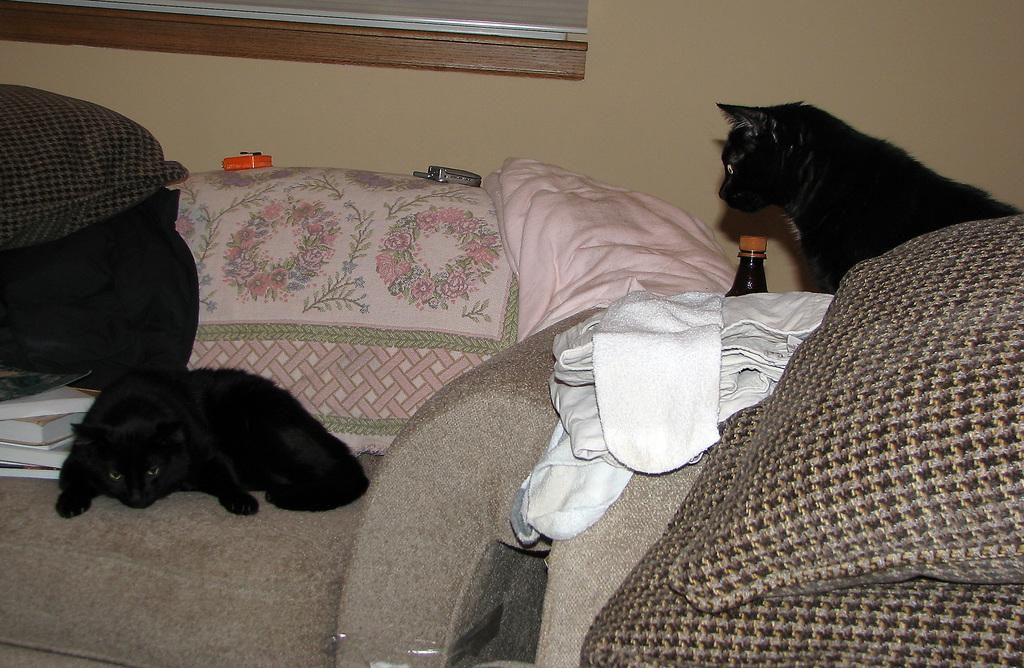What type of animals can be seen in the image? There are cats in the image. What is on the sofa in the image? There are pillows, clothes, and other objects on the sofa. What is visible in the background of the image? There is a wall in the background of the image. What type of nose can be seen on the governor in the image? There is no governor present in the image, and therefore no nose can be observed. What type of basket is visible in the image? There is no basket present in the image. 